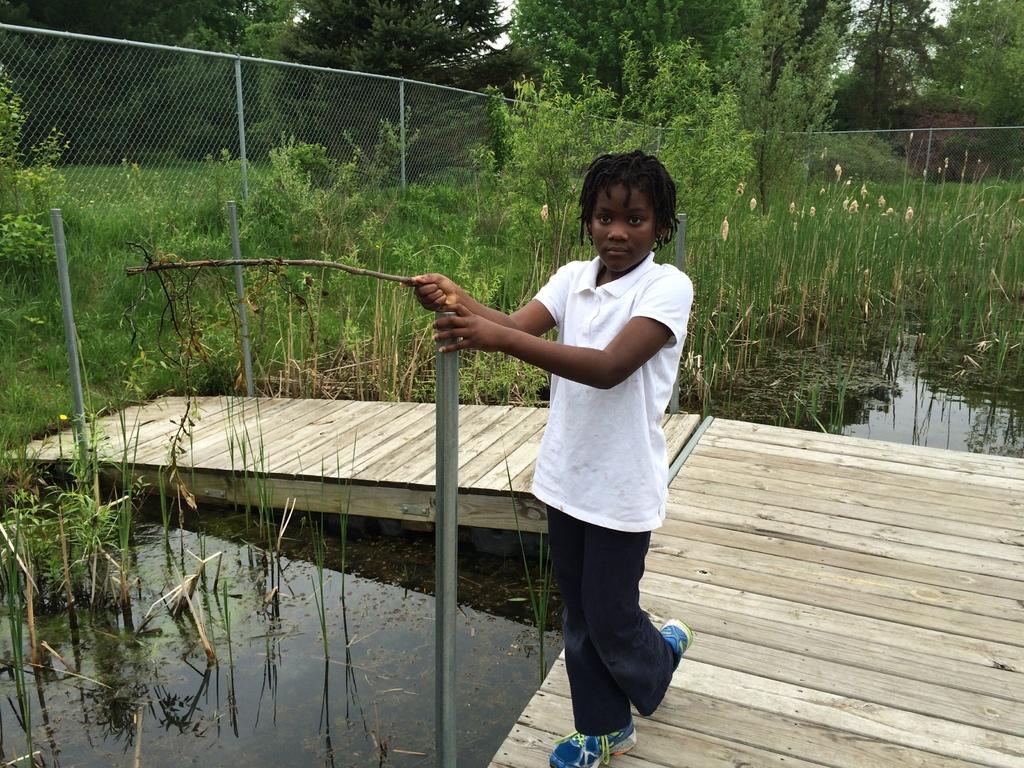Describe this image in one or two sentences. In this image I see a boy who is wearing white t-shirt and black pants and I see that he is holding a rod and a stick and I see the wooden platform and I see the water and I see number of plants. In the background I see the fencing and number of trees and I see few more rods. 